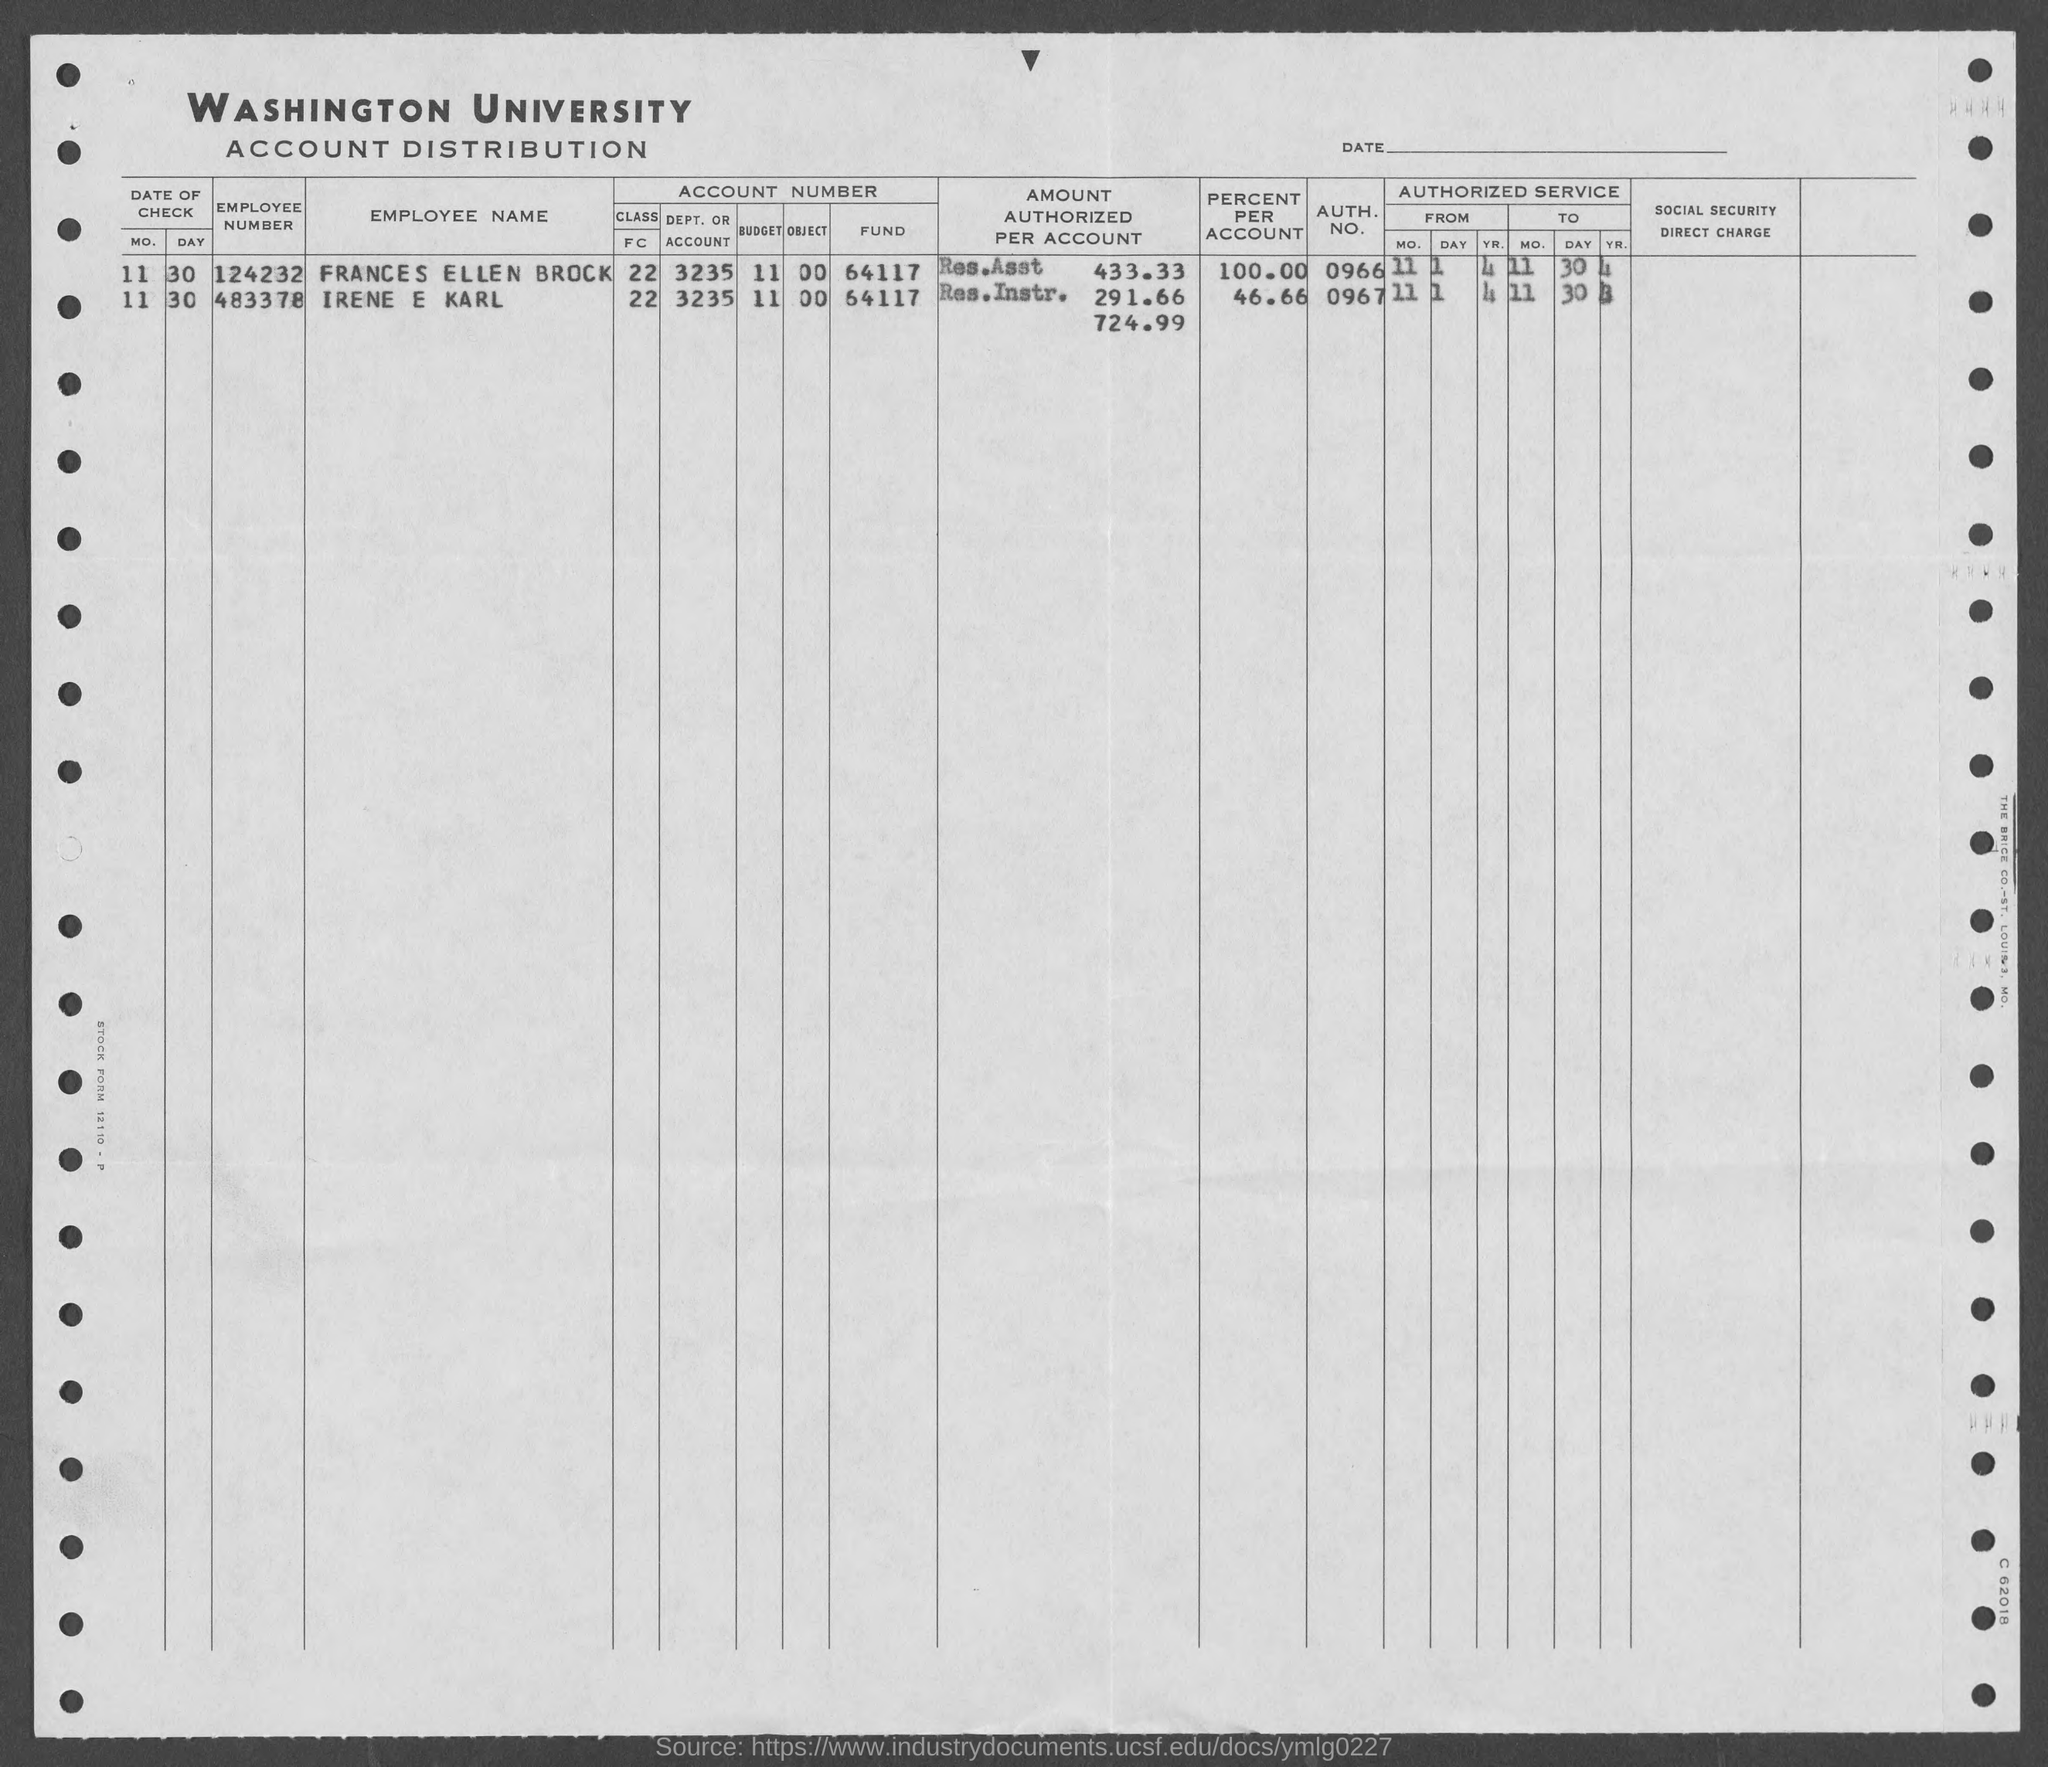List a handful of essential elements in this visual. The employee number of Irene E Karl is 483378. I'm sorry, but I'm not exactly sure what you are trying to say. Could you please clarify your question or provide more context? The unknown person is asking for the authorization number of a woman named Frances Ellen Brock, which is 0966. The query asks for the authentication number of Irene E Karl, with the number being 0967... 